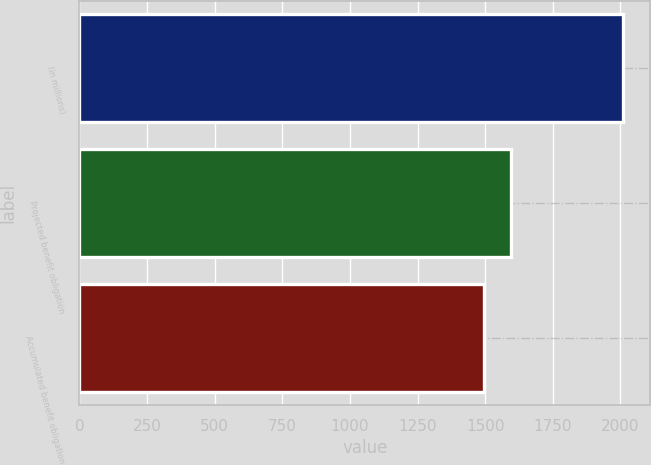Convert chart to OTSL. <chart><loc_0><loc_0><loc_500><loc_500><bar_chart><fcel>(in millions)<fcel>Projected benefit obligation<fcel>Accumulated benefit obligation<nl><fcel>2010<fcel>1594<fcel>1496<nl></chart> 